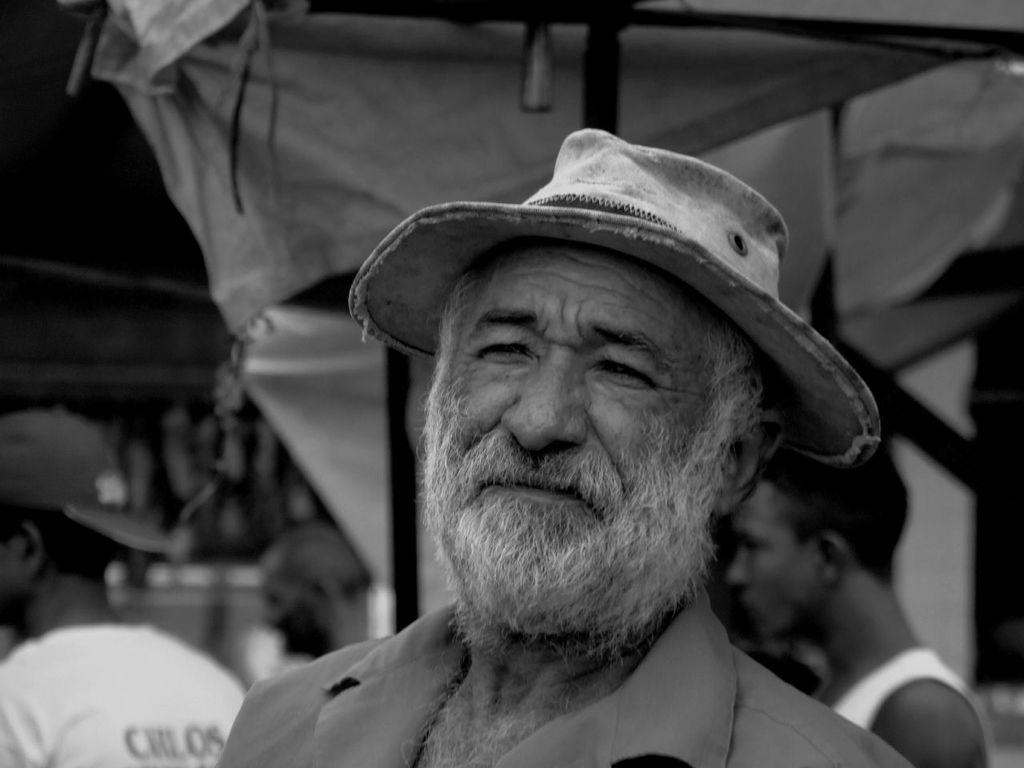What is the color scheme of the image? The image is black and white. Who is the main subject in the image? There is a man wearing a cap in the middle of the image. Can you describe the people in the image? There are there any specific details about them? What can be observed about the background of the image? The background of the image is blurred. How many requests can be seen in the image? There are no requests visible in the image. What type of slip is the man wearing in the image? The man is not wearing a slip in the image; he is wearing a cap. 